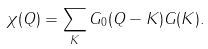<formula> <loc_0><loc_0><loc_500><loc_500>\chi ( Q ) = \sum _ { K } G _ { 0 } ( Q - K ) G ( K ) .</formula> 